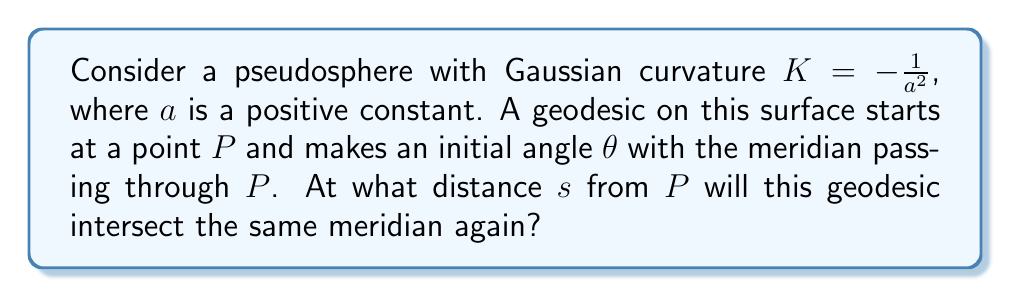Give your solution to this math problem. Let's approach this step-by-step:

1) On a pseudosphere, geodesics that are not meridians behave like helices, winding around the surface.

2) The equation for geodesics on a pseudosphere in terms of the meridional angle $\phi$ and the azimuthal angle $\psi$ is:

   $$\cos\theta = \sinh\frac{\phi}{a}\sin\psi$$

   where $\theta$ is the constant angle the geodesic makes with the meridians.

3) The geodesic will intersect the same meridian when $\psi$ has increased by $2\pi$. At this point:

   $$\cos\theta = \sinh\frac{\phi}{a}$$

4) Solving for $\phi$:

   $$\phi = a \cdot \text{arcsinh}(\cos\theta)$$

5) To find the arc length $s$, we need to integrate the meridional element of arc length:

   $$ds = a\csch\frac{\phi}{a}d\phi$$

6) Integrating from 0 to $\phi$:

   $$s = \int_0^{a\cdot\text{arcsinh}(\cos\theta)} a\csch\frac{\phi}{a}d\phi$$

7) This evaluates to:

   $$s = 2a\ln\left(\tanh\frac{\text{arcsinh}(\cos\theta)}{2}\right)$$

8) Using the identity $\tanh(\text{arcsinh}(x)) = \frac{x}{\sqrt{1+x^2}}$, we get:

   $$s = 2a\ln\left(\frac{\cos\theta}{1+\sin\theta}\right)$$

This is the distance along the geodesic from $P$ to the point where it intersects the same meridian again.
Answer: $s = 2a\ln\left(\frac{\cos\theta}{1+\sin\theta}\right)$ 